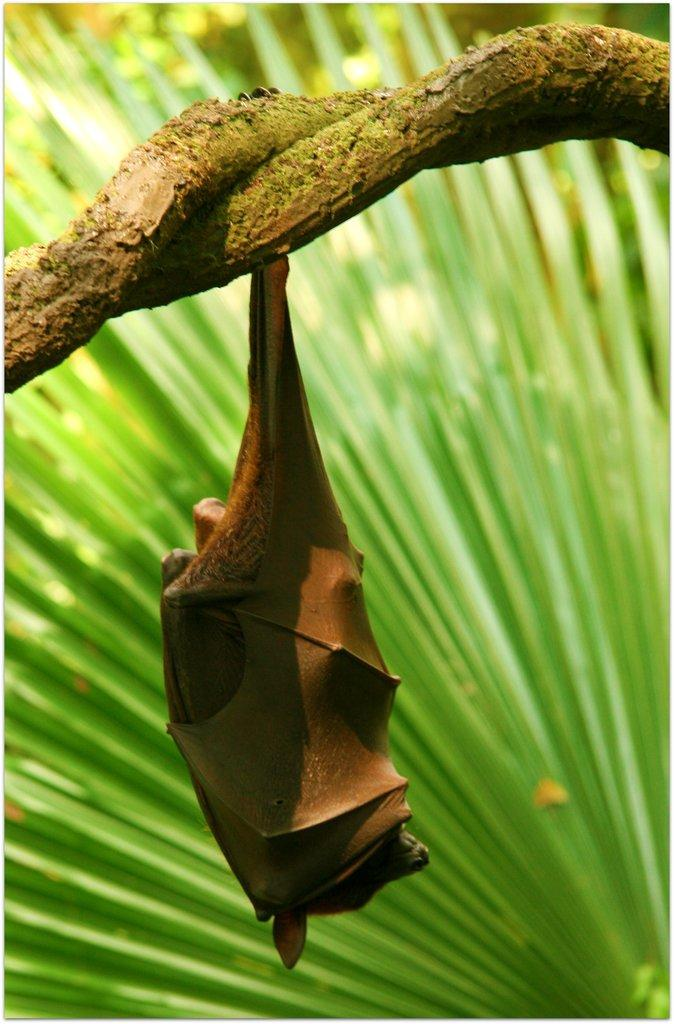What animal is present in the image? There is a bat in the image. How is the bat positioned in the image? The bat is hanging from a branch. What type of environment is visible in the background of the image? There is greenery in the background of the image. What type of roof can be seen on the building in the image? There is no building or roof present in the image; it features a bat hanging from a branch. What color is the flag flying in the image? There is no flag present in the image. 